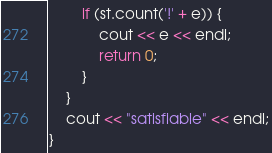<code> <loc_0><loc_0><loc_500><loc_500><_C++_>        if (st.count('!' + e)) {
            cout << e << endl;
            return 0;
        }
    }
    cout << "satisfiable" << endl;
}
</code> 